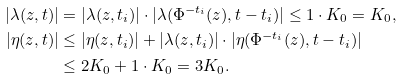Convert formula to latex. <formula><loc_0><loc_0><loc_500><loc_500>| \lambda ( z , t ) | & = | \lambda ( z , t _ { i } ) | \cdot | \lambda ( \Phi ^ { - t _ { i } } ( z ) , t - t _ { i } ) | \leq 1 \cdot K _ { 0 } = K _ { 0 } , \\ | \eta ( z , t ) | & \leq | \eta ( z , t _ { i } ) | + | \lambda ( z , t _ { i } ) | \cdot | \eta ( \Phi ^ { - t _ { i } } ( z ) , t - t _ { i } ) | \\ & \leq 2 K _ { 0 } + 1 \cdot K _ { 0 } = 3 K _ { 0 } .</formula> 